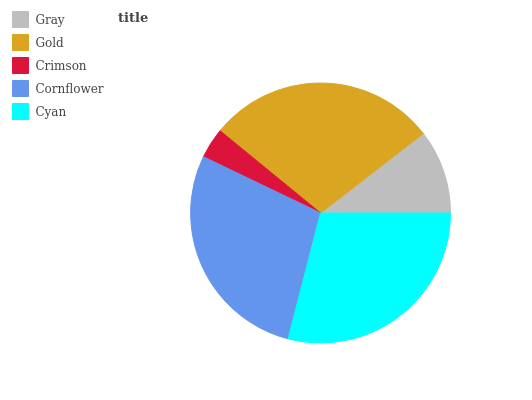Is Crimson the minimum?
Answer yes or no. Yes. Is Cyan the maximum?
Answer yes or no. Yes. Is Gold the minimum?
Answer yes or no. No. Is Gold the maximum?
Answer yes or no. No. Is Gold greater than Gray?
Answer yes or no. Yes. Is Gray less than Gold?
Answer yes or no. Yes. Is Gray greater than Gold?
Answer yes or no. No. Is Gold less than Gray?
Answer yes or no. No. Is Cornflower the high median?
Answer yes or no. Yes. Is Cornflower the low median?
Answer yes or no. Yes. Is Crimson the high median?
Answer yes or no. No. Is Crimson the low median?
Answer yes or no. No. 